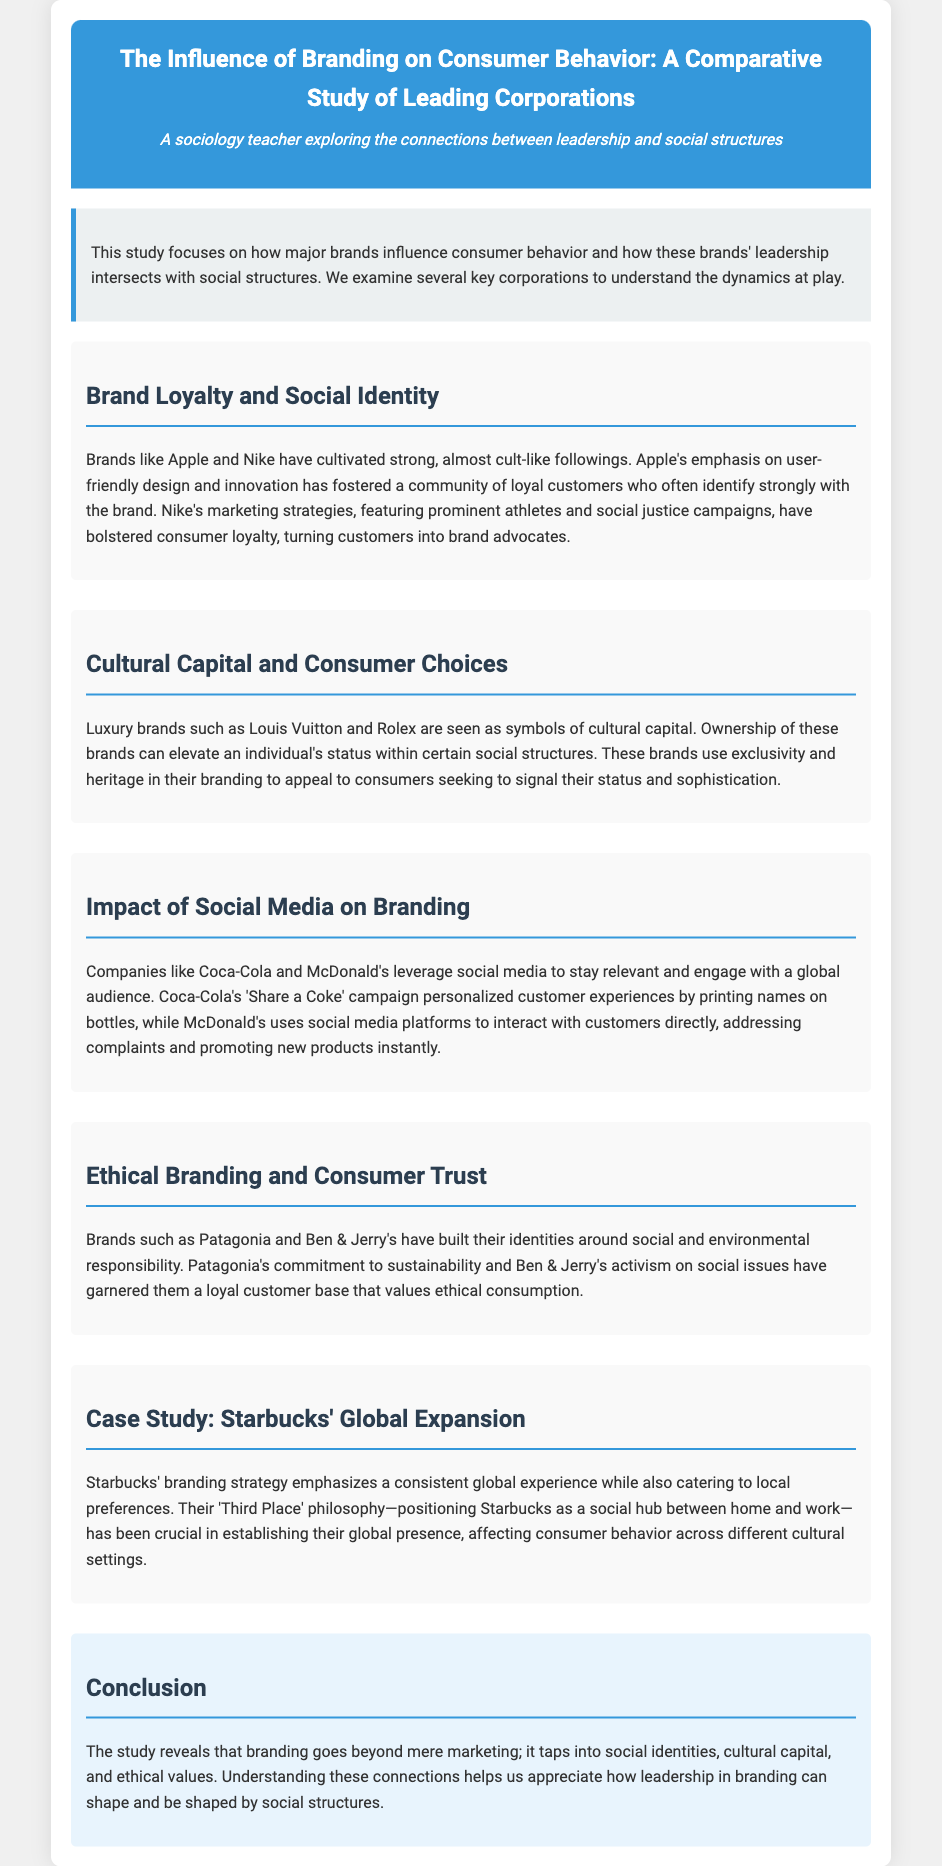What is the main focus of the study? The study focuses on how major brands influence consumer behavior and how these brands' leadership intersects with social structures.
Answer: major brands influence consumer behavior Which company is mentioned in the section about brand loyalty? Apple is highlighted as a brand that has cultivated a strong following.
Answer: Apple What is the 'Third Place' philosophy associated with? Starbucks' branding strategy emphasizes the 'Third Place' philosophy.
Answer: Starbucks What ethical values are associated with Patagonia? Patagonia is identified with a commitment to sustainability.
Answer: sustainability What marketing strategy did Coca-Cola use to personalize customer experiences? Coca-Cola's 'Share a Coke' campaign printed names on bottles.
Answer: 'Share a Coke' campaign How do luxury brands like Louis Vuitton and Rolex impact social structures? They are seen as symbols of cultural capital that elevate an individual's status.
Answer: cultural capital Which company's marketing features prominent athletes and social justice campaigns? Nike's marketing strategies feature prominent athletes and social justice campaigns.
Answer: Nike What do brands like Ben & Jerry's build their identity around? Ben & Jerry's builds its identity around social and environmental responsibility.
Answer: social and environmental responsibility 